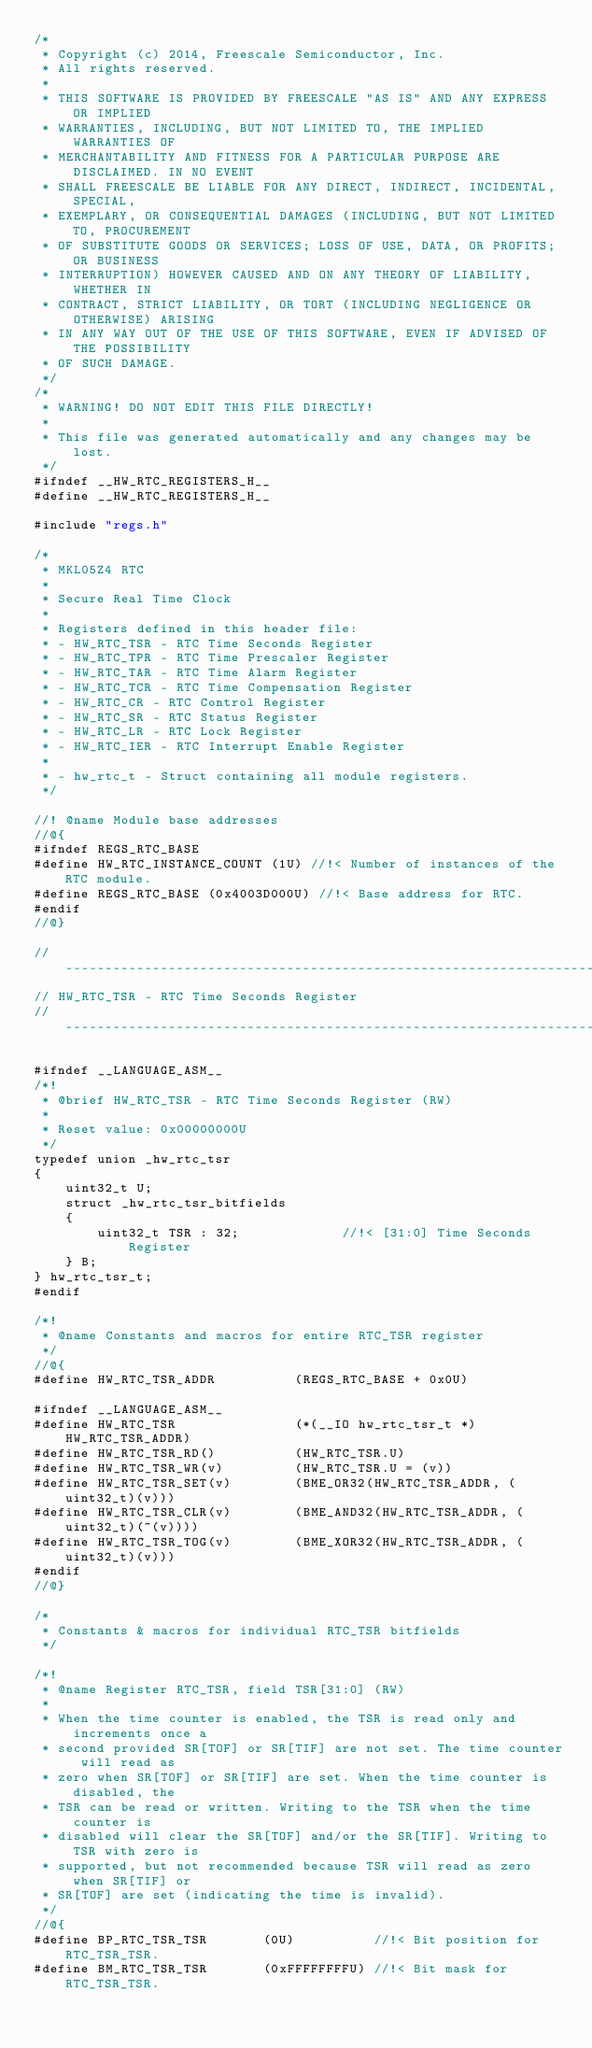Convert code to text. <code><loc_0><loc_0><loc_500><loc_500><_C_>/*
 * Copyright (c) 2014, Freescale Semiconductor, Inc.
 * All rights reserved.
 *
 * THIS SOFTWARE IS PROVIDED BY FREESCALE "AS IS" AND ANY EXPRESS OR IMPLIED
 * WARRANTIES, INCLUDING, BUT NOT LIMITED TO, THE IMPLIED WARRANTIES OF
 * MERCHANTABILITY AND FITNESS FOR A PARTICULAR PURPOSE ARE DISCLAIMED. IN NO EVENT
 * SHALL FREESCALE BE LIABLE FOR ANY DIRECT, INDIRECT, INCIDENTAL, SPECIAL,
 * EXEMPLARY, OR CONSEQUENTIAL DAMAGES (INCLUDING, BUT NOT LIMITED TO, PROCUREMENT
 * OF SUBSTITUTE GOODS OR SERVICES; LOSS OF USE, DATA, OR PROFITS; OR BUSINESS
 * INTERRUPTION) HOWEVER CAUSED AND ON ANY THEORY OF LIABILITY, WHETHER IN
 * CONTRACT, STRICT LIABILITY, OR TORT (INCLUDING NEGLIGENCE OR OTHERWISE) ARISING
 * IN ANY WAY OUT OF THE USE OF THIS SOFTWARE, EVEN IF ADVISED OF THE POSSIBILITY
 * OF SUCH DAMAGE.
 */
/*
 * WARNING! DO NOT EDIT THIS FILE DIRECTLY!
 *
 * This file was generated automatically and any changes may be lost.
 */
#ifndef __HW_RTC_REGISTERS_H__
#define __HW_RTC_REGISTERS_H__

#include "regs.h"

/*
 * MKL05Z4 RTC
 *
 * Secure Real Time Clock
 *
 * Registers defined in this header file:
 * - HW_RTC_TSR - RTC Time Seconds Register
 * - HW_RTC_TPR - RTC Time Prescaler Register
 * - HW_RTC_TAR - RTC Time Alarm Register
 * - HW_RTC_TCR - RTC Time Compensation Register
 * - HW_RTC_CR - RTC Control Register
 * - HW_RTC_SR - RTC Status Register
 * - HW_RTC_LR - RTC Lock Register
 * - HW_RTC_IER - RTC Interrupt Enable Register
 *
 * - hw_rtc_t - Struct containing all module registers.
 */

//! @name Module base addresses
//@{
#ifndef REGS_RTC_BASE
#define HW_RTC_INSTANCE_COUNT (1U) //!< Number of instances of the RTC module.
#define REGS_RTC_BASE (0x4003D000U) //!< Base address for RTC.
#endif
//@}

//-------------------------------------------------------------------------------------------
// HW_RTC_TSR - RTC Time Seconds Register
//-------------------------------------------------------------------------------------------

#ifndef __LANGUAGE_ASM__
/*!
 * @brief HW_RTC_TSR - RTC Time Seconds Register (RW)
 *
 * Reset value: 0x00000000U
 */
typedef union _hw_rtc_tsr
{
    uint32_t U;
    struct _hw_rtc_tsr_bitfields
    {
        uint32_t TSR : 32;             //!< [31:0] Time Seconds Register
    } B;
} hw_rtc_tsr_t;
#endif

/*!
 * @name Constants and macros for entire RTC_TSR register
 */
//@{
#define HW_RTC_TSR_ADDR          (REGS_RTC_BASE + 0x0U)

#ifndef __LANGUAGE_ASM__
#define HW_RTC_TSR               (*(__IO hw_rtc_tsr_t *) HW_RTC_TSR_ADDR)
#define HW_RTC_TSR_RD()          (HW_RTC_TSR.U)
#define HW_RTC_TSR_WR(v)         (HW_RTC_TSR.U = (v))
#define HW_RTC_TSR_SET(v)        (BME_OR32(HW_RTC_TSR_ADDR, (uint32_t)(v)))
#define HW_RTC_TSR_CLR(v)        (BME_AND32(HW_RTC_TSR_ADDR, (uint32_t)(~(v))))
#define HW_RTC_TSR_TOG(v)        (BME_XOR32(HW_RTC_TSR_ADDR, (uint32_t)(v)))
#endif
//@}

/*
 * Constants & macros for individual RTC_TSR bitfields
 */

/*!
 * @name Register RTC_TSR, field TSR[31:0] (RW)
 *
 * When the time counter is enabled, the TSR is read only and increments once a
 * second provided SR[TOF] or SR[TIF] are not set. The time counter will read as
 * zero when SR[TOF] or SR[TIF] are set. When the time counter is disabled, the
 * TSR can be read or written. Writing to the TSR when the time counter is
 * disabled will clear the SR[TOF] and/or the SR[TIF]. Writing to TSR with zero is
 * supported, but not recommended because TSR will read as zero when SR[TIF] or
 * SR[TOF] are set (indicating the time is invalid).
 */
//@{
#define BP_RTC_TSR_TSR       (0U)          //!< Bit position for RTC_TSR_TSR.
#define BM_RTC_TSR_TSR       (0xFFFFFFFFU) //!< Bit mask for RTC_TSR_TSR.</code> 